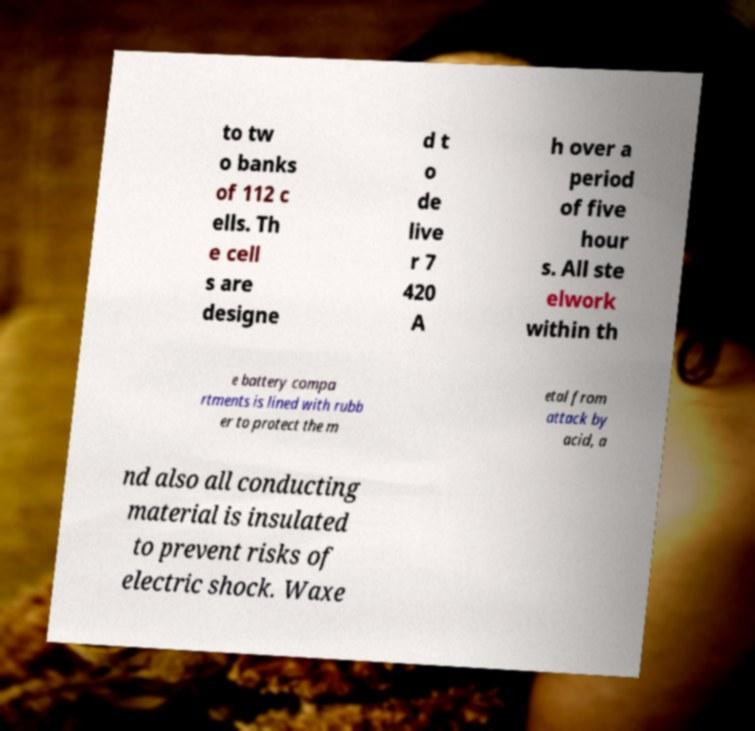Can you read and provide the text displayed in the image?This photo seems to have some interesting text. Can you extract and type it out for me? to tw o banks of 112 c ells. Th e cell s are designe d t o de live r 7 420 A h over a period of five hour s. All ste elwork within th e battery compa rtments is lined with rubb er to protect the m etal from attack by acid, a nd also all conducting material is insulated to prevent risks of electric shock. Waxe 